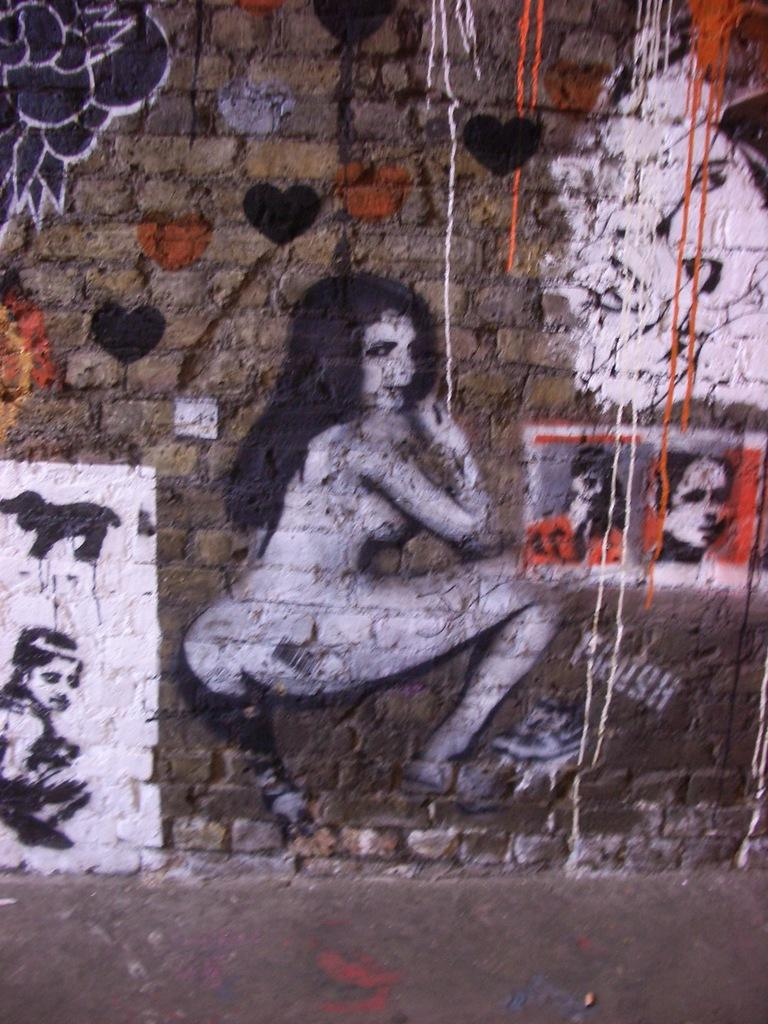What is depicted on the wall in the image? There is a wall painting in the image. What can be seen in the wall painting? The wall painting contains people. What colors are used in the wall painting? The painting colors include black, red, and white. What type of bun is being used to hold the painting on the wall? There is no bun present in the image; the painting is directly applied to the wall. 